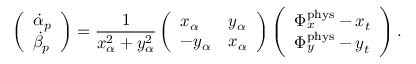<formula> <loc_0><loc_0><loc_500><loc_500>\left ( \begin{array} { l } { \dot { \alpha } _ { p } } \\ { \dot { \beta } _ { p } } \end{array} \right ) = \frac { 1 } { x _ { \alpha } ^ { 2 } + y _ { \alpha } ^ { 2 } } \left ( \begin{array} { l l } { x _ { \alpha } } & { y _ { \alpha } } \\ { - y _ { \alpha } } & { x _ { \alpha } } \end{array} \right ) \left ( \begin{array} { l } { \Phi _ { x } ^ { p h y s } - x _ { t } } \\ { \Phi _ { y } ^ { p h y s } - y _ { t } } \end{array} \right ) .</formula> 